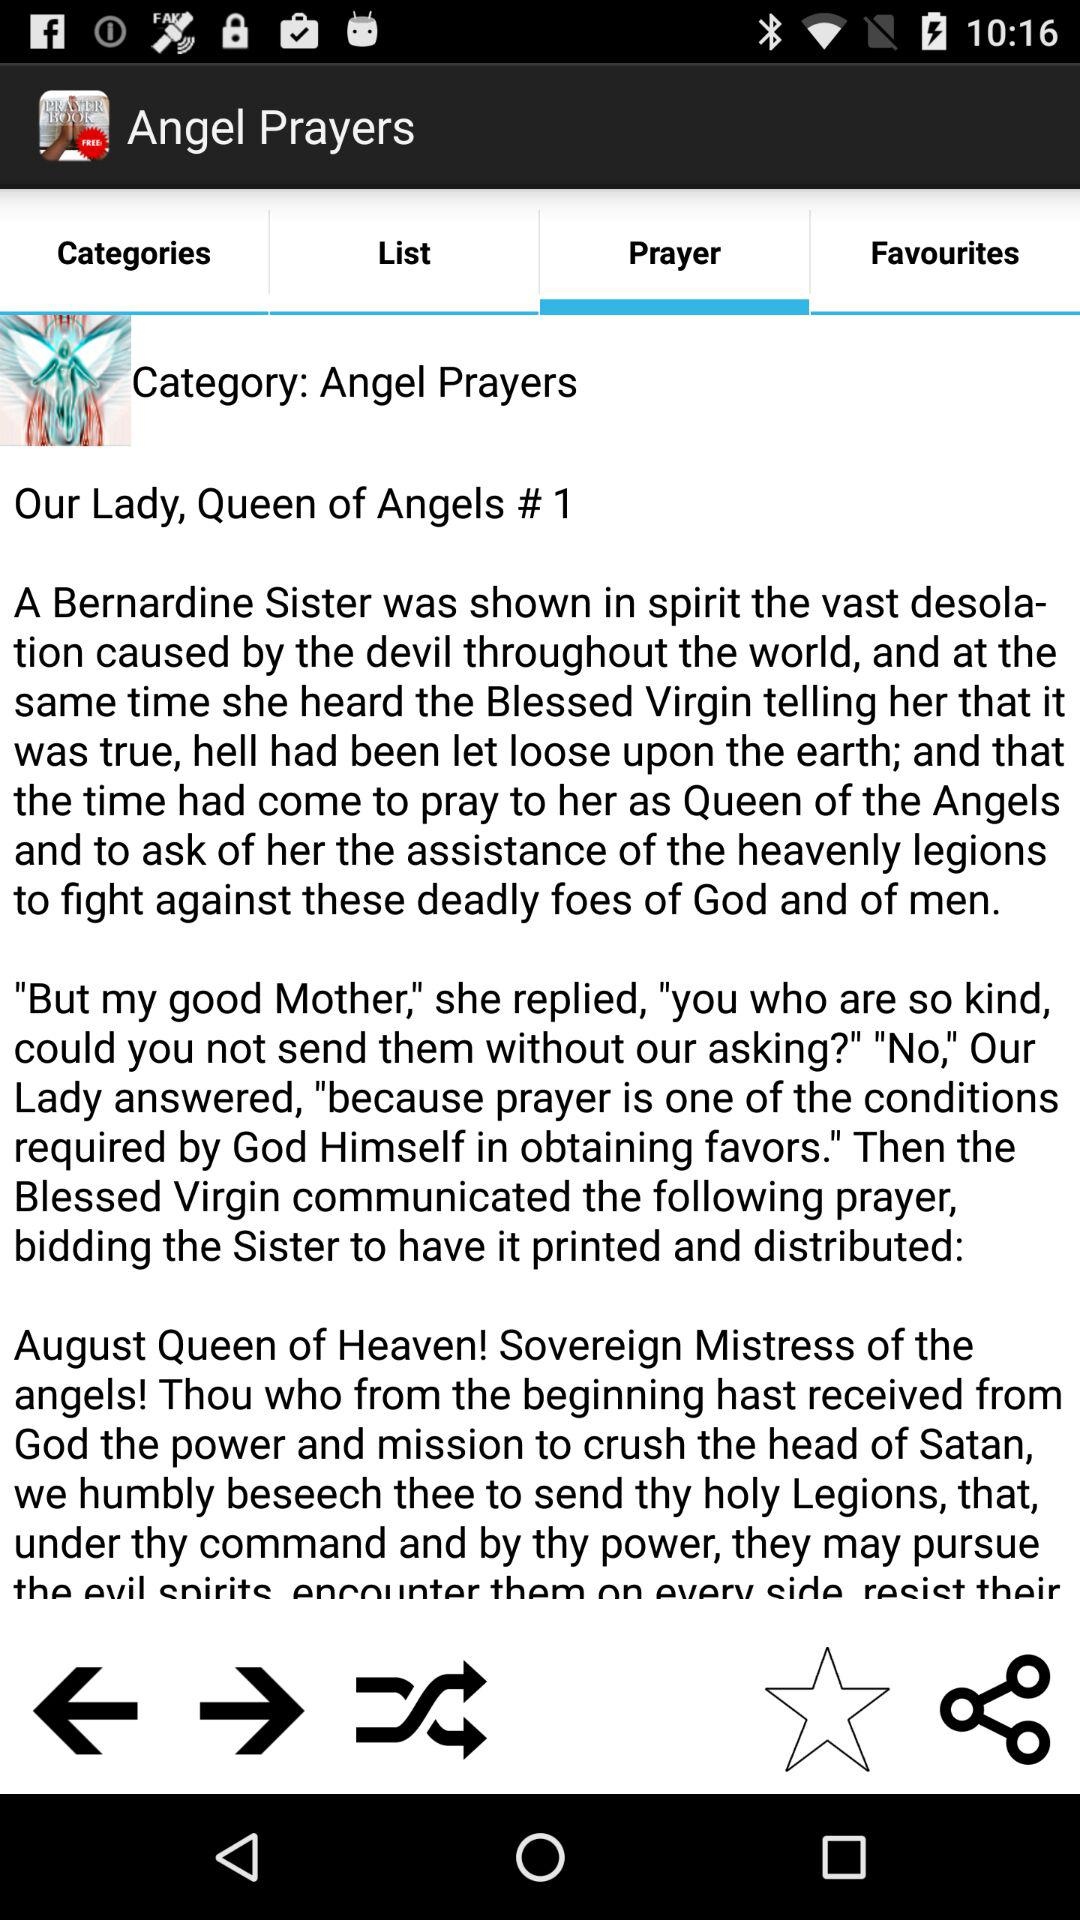Which tab is selected? The selected tab is "Prayer". 